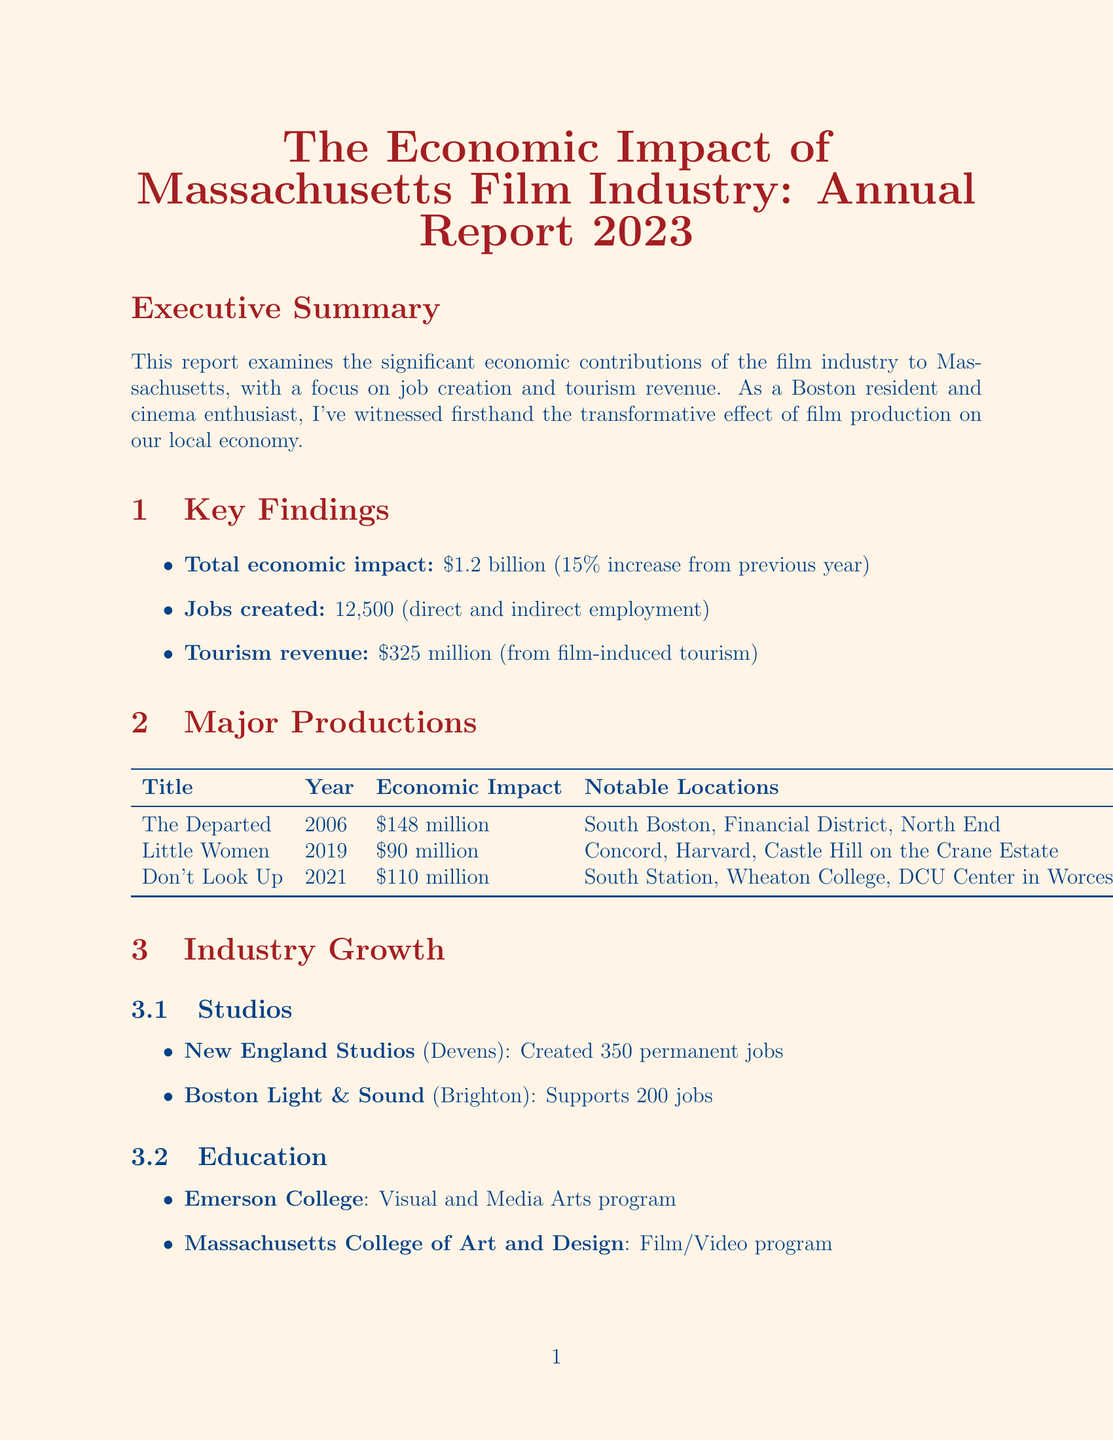what is the total economic impact of the film industry in Massachusetts? The total economic impact is highlighted in the key findings section of the report.
Answer: $1.2 billion how many jobs were created by the film industry in Massachusetts? The number of jobs created is detailed in the key findings section.
Answer: 12,500 what was the tourism revenue generated from film-induced tourism? The tourism revenue is provided in the key findings section of the report.
Answer: $325 million which film contributed $90 million to the economy? The economic impact of each major production is listed in the major productions section.
Answer: Little Women what is the projected economic impact for 2024? Future projections include expected economic impact figures for the upcoming year.
Answer: $1.4 billion how many jobs did New England Studios create? The impact of New England Studios is detailed in the industry growth section under studios.
Answer: 350 what notable location is associated with the film "Don't Look Up"? Notable locations for each major production are outlined in the major productions section.
Answer: South Station how many visitors does the Good Will Hunting Bench attract annually? The annual visitor count for tourist attractions is provided in the tourism highlights section.
Answer: 100,000 which college offers a program in Visual and Media Arts? The education section lists institutions contributing to the local talent pool.
Answer: Emerson College 